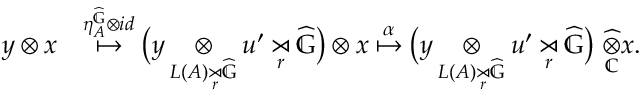Convert formula to latex. <formula><loc_0><loc_0><loc_500><loc_500>\begin{array} { r l } { y \otimes x } & { \overset { \eta _ { A } ^ { \widehat { \mathbb { G } } } \otimes i d } { \mapsto } \left ( y \underset { L ( A ) \underset { r } { \rtimes } \widehat { \mathbb { G } } } { \otimes } u ^ { \prime } \underset { r } { \rtimes } \widehat { \mathbb { G } } \right ) \otimes x \overset { \alpha } { \mapsto } \left ( y \underset { L ( A ) \underset { r } { \rtimes } \widehat { \mathbb { G } } } { \otimes } u ^ { \prime } \underset { r } { \rtimes } \widehat { \mathbb { G } } \right ) \ \underset { \mathbb { C } } { \widehat { \otimes } } x . } \end{array}</formula> 